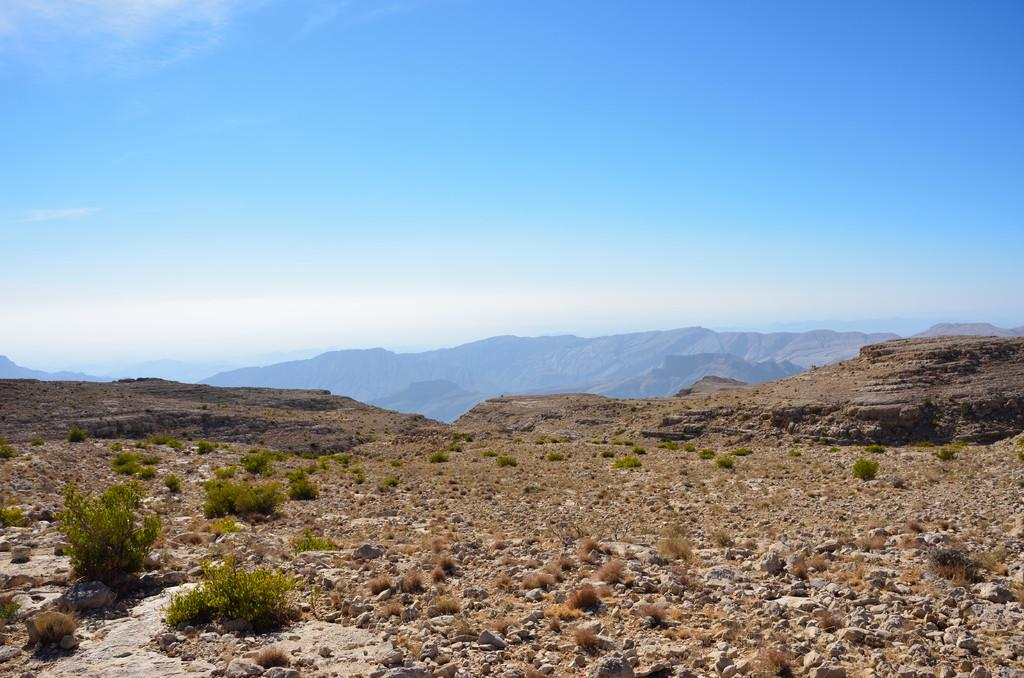What celestial bodies are depicted in the image? There are planets in the image. What type of geographical feature can be seen in the image? There are hills in the image. What part of the natural environment is visible in the image? The sky is visible in the image. What type of jam is being served in the church in the image? There is no jam or church present in the image; it features planets and hills. 